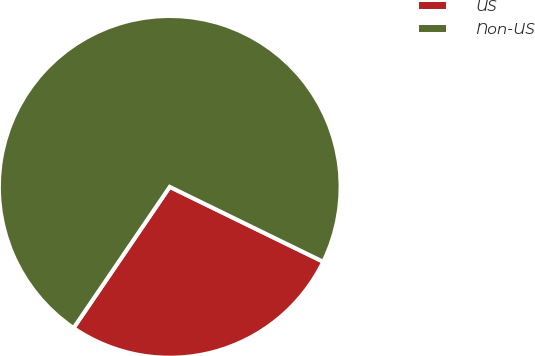Convert chart to OTSL. <chart><loc_0><loc_0><loc_500><loc_500><pie_chart><fcel>US<fcel>Non-US<nl><fcel>27.29%<fcel>72.71%<nl></chart> 